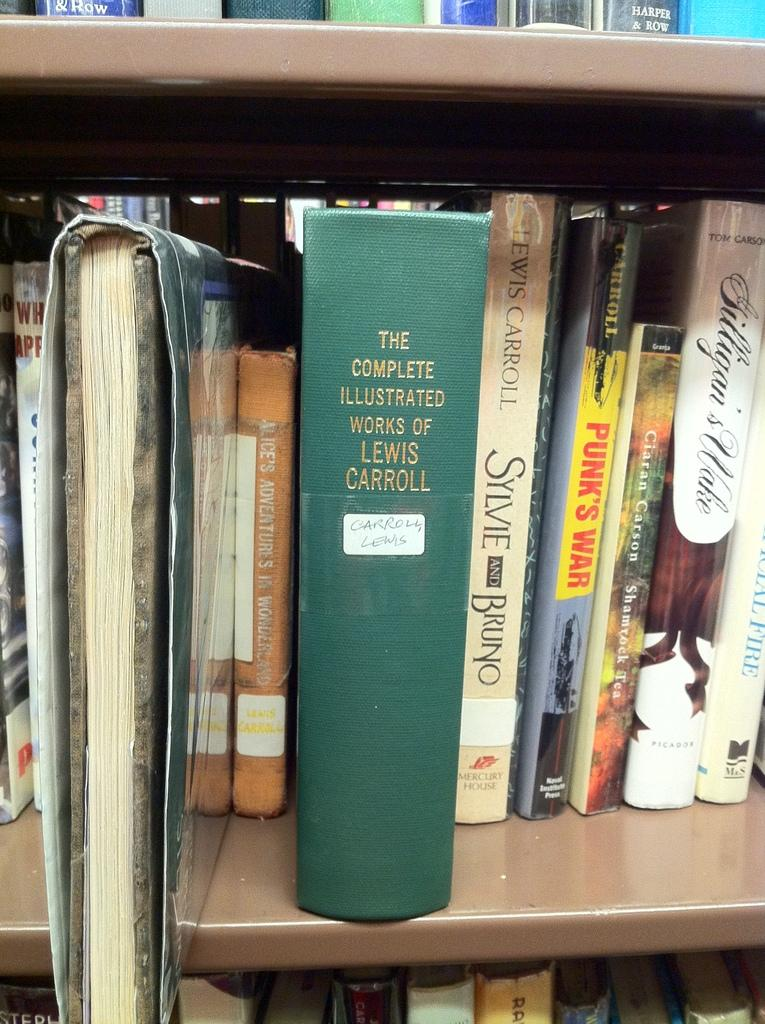<image>
Summarize the visual content of the image. A bookshelf with a large green book called The Complete Illustrated Works of Lewis Carroll. 